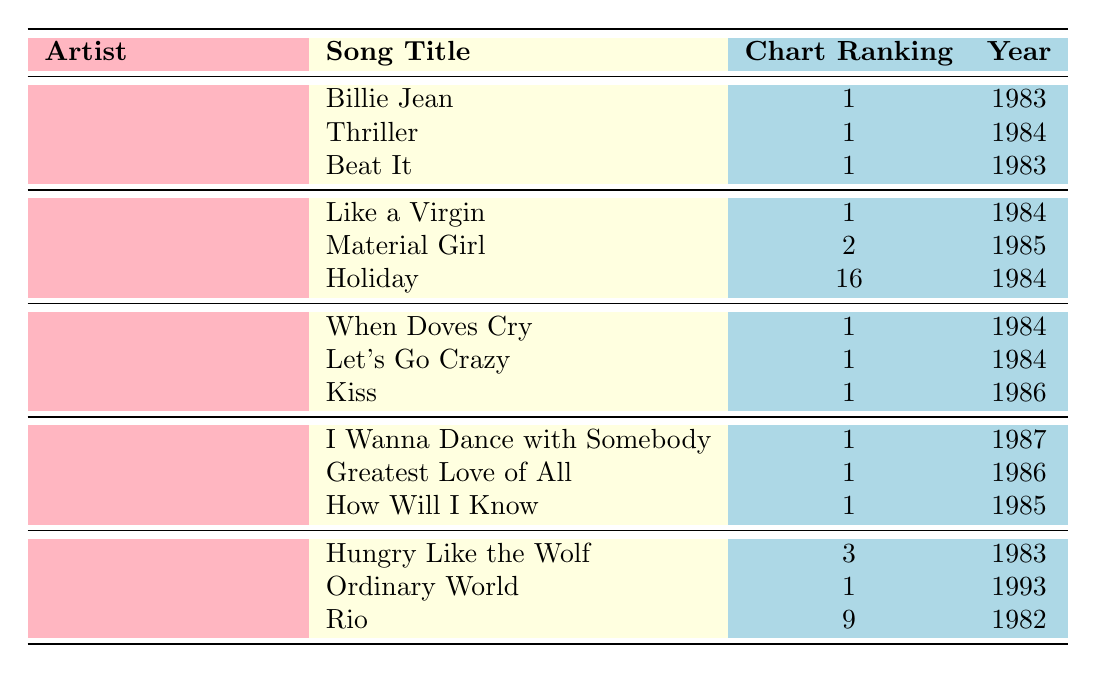What's the top-charting song of Michael Jackson? The table lists Michael Jackson's songs, among which "Billie Jean", "Thriller", and "Beat It" all have a chart ranking of 1. Therefore, any of these songs can be considered his top-charting songs.
Answer: Billie Jean, Thriller, Beat It How many songs did Madonna achieve a rank of 1? According to the table, Madonna has one song, "Like a Virgin," that achieved a ranking of 1. This is the only entry under her name that indicates a top rank.
Answer: 1 Which artist had the most songs with a chart ranking of 1? By examining the table, both Michael Jackson, Prince, and Whitney Houston each have three songs that reached a chart ranking of 1. Therefore, they share this top position.
Answer: Michael Jackson, Prince, Whitney Houston Did Duran Duran have any songs that reached number one? The table shows that Duran Duran had only one song, "Ordinary World," that achieved a ranking of 1, meaning they were successful in reaching the top spot at least once.
Answer: Yes What is the average chart ranking of Madonna's top songs? To find the average, add Madonna's songs' rankings (1 + 2 + 16 = 19) and divide by the number of songs (3). Thus, the average ranking is 19/3, which is approximately 6.33.
Answer: 6.33 How many years span the songs listed for Prince? Looking at Prince's top songs, the years are 1984, 1984, and 1986. The range from the earliest year (1984) to the latest year (1986) indicates a span of 2 years.
Answer: 2 years What is the lowest chart ranking among all artists in the table? By reviewing all the chart rankings, "Holiday" by Madonna has the lowest ranking at 16, which is higher numerically than the other rankings that are all 1 or less.
Answer: 16 Which artist had songs in both the early 80s and late 80s? The table reveals that Whitney Houston's songs span 1985 to 1987, so she is the only artist whose songs fall into both early and late 80s.
Answer: Whitney Houston 